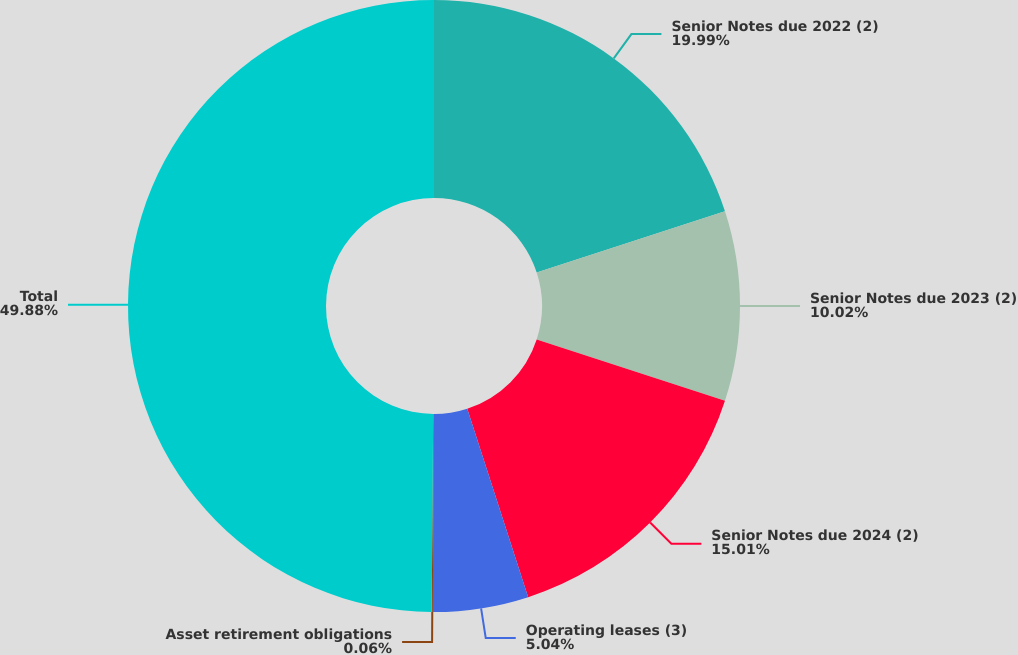Convert chart. <chart><loc_0><loc_0><loc_500><loc_500><pie_chart><fcel>Senior Notes due 2022 (2)<fcel>Senior Notes due 2023 (2)<fcel>Senior Notes due 2024 (2)<fcel>Operating leases (3)<fcel>Asset retirement obligations<fcel>Total<nl><fcel>19.99%<fcel>10.02%<fcel>15.01%<fcel>5.04%<fcel>0.06%<fcel>49.88%<nl></chart> 